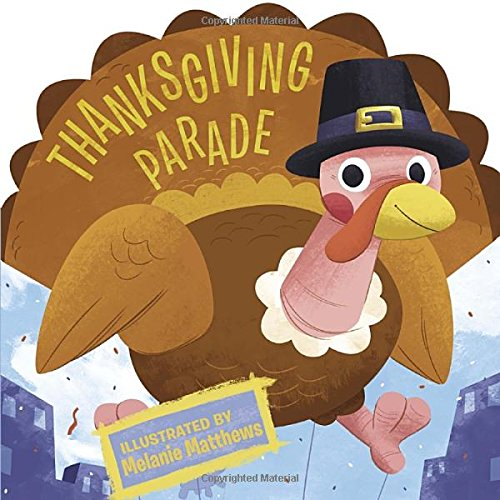Is this book related to Sports & Outdoors? No, this book is not related to Sports & Outdoors. It's a children's book with a focus on the Thanksgiving holiday. 